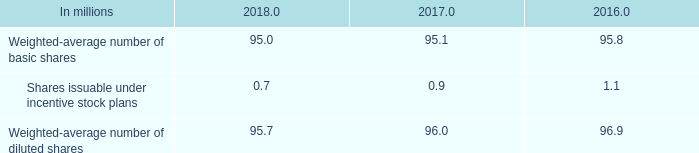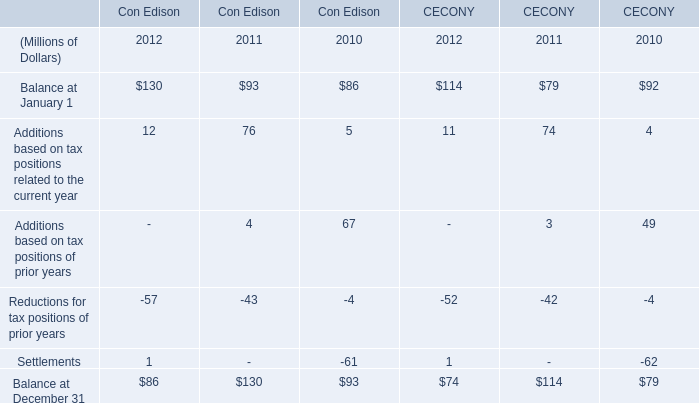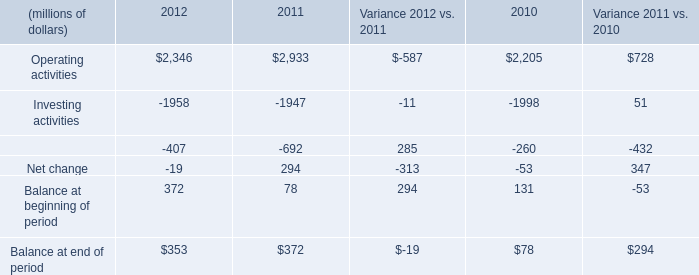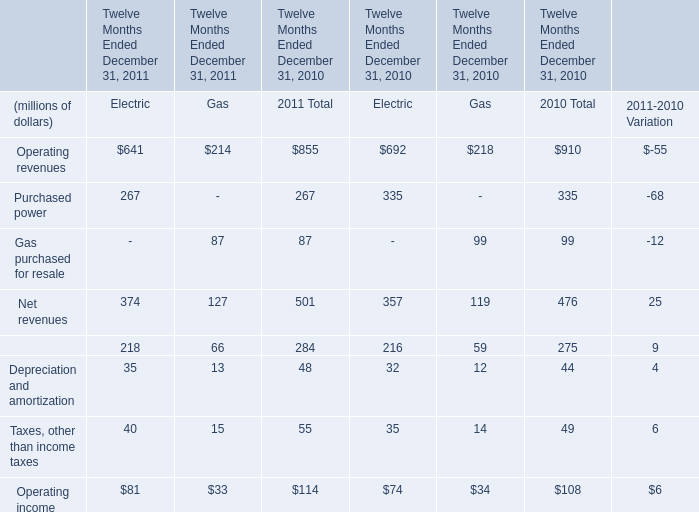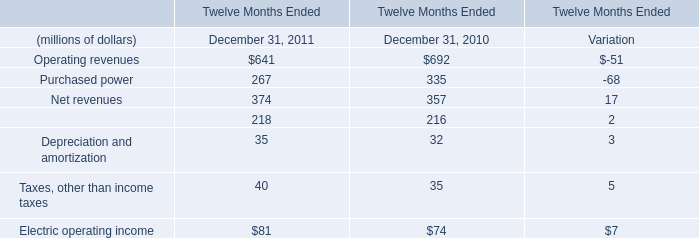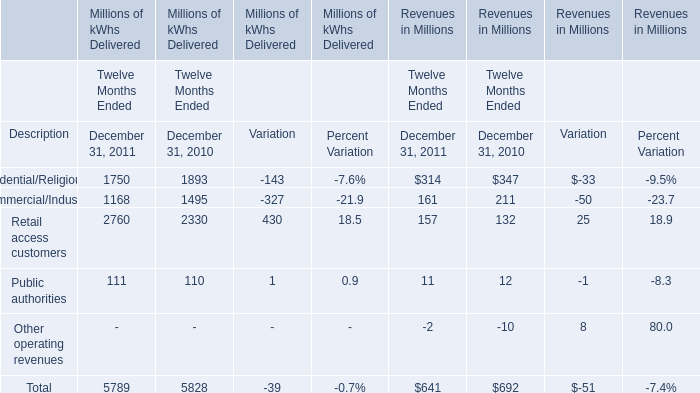If Electric operating income develops with the same growth rate in 2011, what will it reach in 2012? (in million) 
Computations: (81 * (1 + ((81 - 74) / 74)))
Answer: 88.66216. 